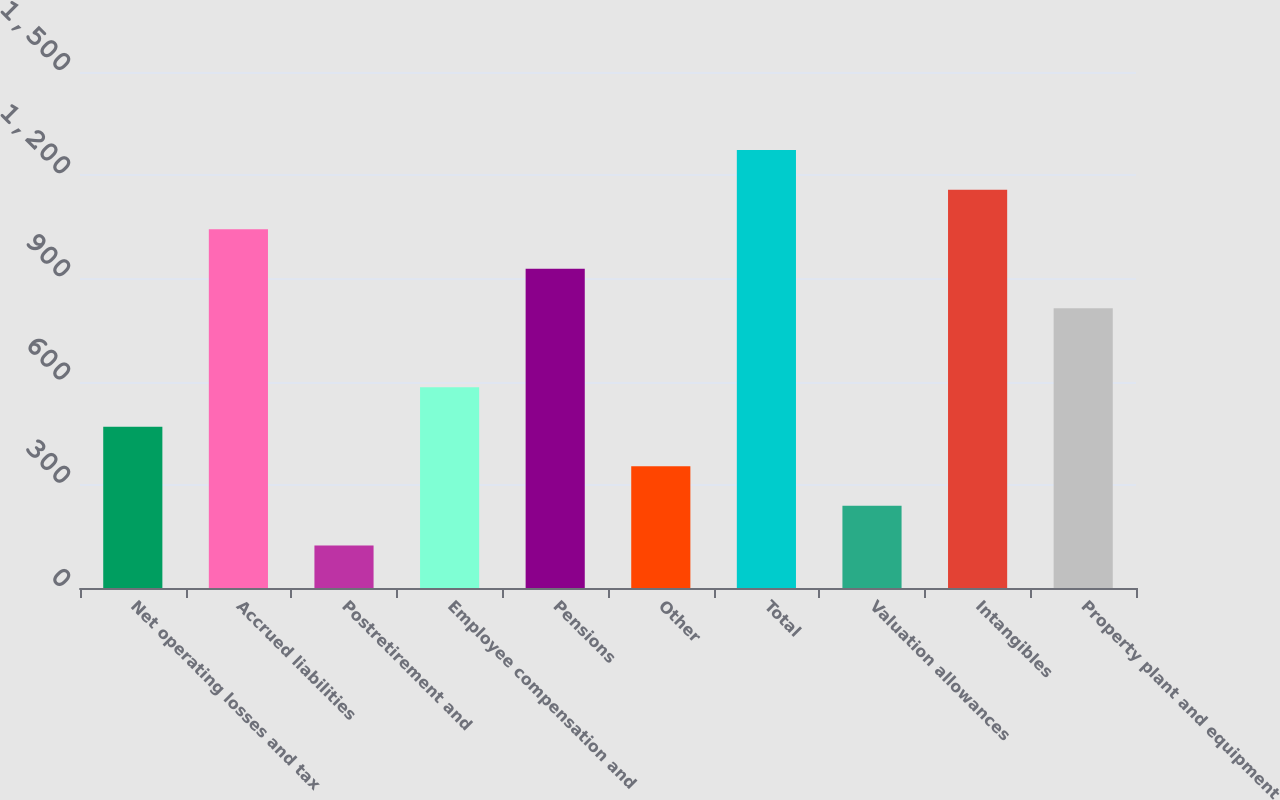Convert chart. <chart><loc_0><loc_0><loc_500><loc_500><bar_chart><fcel>Net operating losses and tax<fcel>Accrued liabilities<fcel>Postretirement and<fcel>Employee compensation and<fcel>Pensions<fcel>Other<fcel>Total<fcel>Valuation allowances<fcel>Intangibles<fcel>Property plant and equipment<nl><fcel>468.6<fcel>1043.1<fcel>123.9<fcel>583.5<fcel>928.2<fcel>353.7<fcel>1272.9<fcel>238.8<fcel>1158<fcel>813.3<nl></chart> 